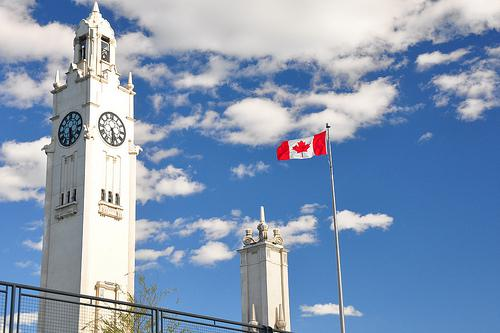Question: how many people are in this photo?
Choices:
A. One.
B. None.
C. Two.
D. Three.
Answer with the letter. Answer: B Question: where is the clock?
Choices:
A. On the clock tower.
B. On the building on the left.
C. On the stove.
D. On the man's wrist.
Answer with the letter. Answer: B Question: what kind of flag is shown?
Choices:
A. American.
B. British.
C. Canadian.
D. Scottish.
Answer with the letter. Answer: C 